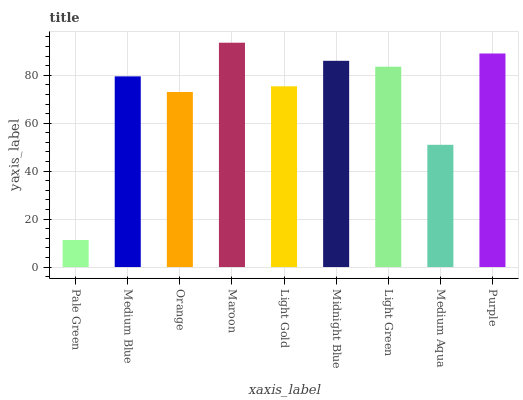Is Pale Green the minimum?
Answer yes or no. Yes. Is Maroon the maximum?
Answer yes or no. Yes. Is Medium Blue the minimum?
Answer yes or no. No. Is Medium Blue the maximum?
Answer yes or no. No. Is Medium Blue greater than Pale Green?
Answer yes or no. Yes. Is Pale Green less than Medium Blue?
Answer yes or no. Yes. Is Pale Green greater than Medium Blue?
Answer yes or no. No. Is Medium Blue less than Pale Green?
Answer yes or no. No. Is Medium Blue the high median?
Answer yes or no. Yes. Is Medium Blue the low median?
Answer yes or no. Yes. Is Orange the high median?
Answer yes or no. No. Is Maroon the low median?
Answer yes or no. No. 